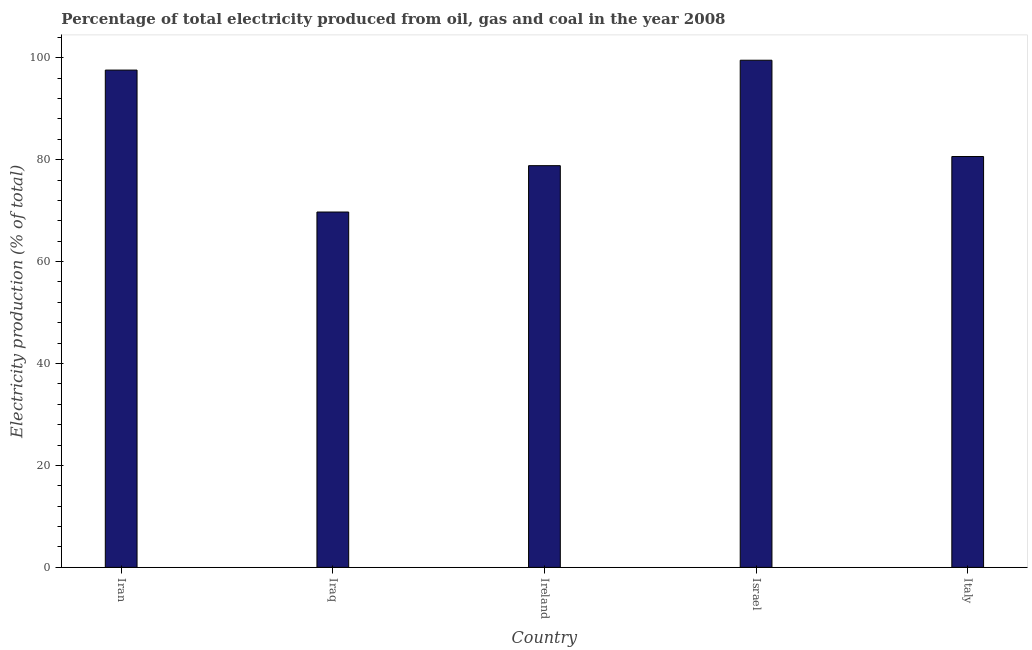Does the graph contain any zero values?
Offer a very short reply. No. What is the title of the graph?
Offer a very short reply. Percentage of total electricity produced from oil, gas and coal in the year 2008. What is the label or title of the Y-axis?
Offer a very short reply. Electricity production (% of total). What is the electricity production in Ireland?
Your answer should be compact. 78.82. Across all countries, what is the maximum electricity production?
Your answer should be compact. 99.51. Across all countries, what is the minimum electricity production?
Make the answer very short. 69.72. In which country was the electricity production maximum?
Keep it short and to the point. Israel. In which country was the electricity production minimum?
Your response must be concise. Iraq. What is the sum of the electricity production?
Offer a terse response. 426.25. What is the difference between the electricity production in Ireland and Israel?
Offer a very short reply. -20.69. What is the average electricity production per country?
Ensure brevity in your answer.  85.25. What is the median electricity production?
Ensure brevity in your answer.  80.61. What is the difference between the highest and the second highest electricity production?
Give a very brief answer. 1.93. What is the difference between the highest and the lowest electricity production?
Your answer should be very brief. 29.78. How many countries are there in the graph?
Your response must be concise. 5. What is the difference between two consecutive major ticks on the Y-axis?
Give a very brief answer. 20. Are the values on the major ticks of Y-axis written in scientific E-notation?
Offer a terse response. No. What is the Electricity production (% of total) of Iran?
Your answer should be compact. 97.58. What is the Electricity production (% of total) of Iraq?
Your answer should be very brief. 69.72. What is the Electricity production (% of total) of Ireland?
Keep it short and to the point. 78.82. What is the Electricity production (% of total) of Israel?
Provide a succinct answer. 99.51. What is the Electricity production (% of total) in Italy?
Your response must be concise. 80.61. What is the difference between the Electricity production (% of total) in Iran and Iraq?
Offer a terse response. 27.85. What is the difference between the Electricity production (% of total) in Iran and Ireland?
Provide a succinct answer. 18.75. What is the difference between the Electricity production (% of total) in Iran and Israel?
Make the answer very short. -1.93. What is the difference between the Electricity production (% of total) in Iran and Italy?
Your response must be concise. 16.96. What is the difference between the Electricity production (% of total) in Iraq and Ireland?
Give a very brief answer. -9.1. What is the difference between the Electricity production (% of total) in Iraq and Israel?
Your answer should be compact. -29.78. What is the difference between the Electricity production (% of total) in Iraq and Italy?
Provide a succinct answer. -10.89. What is the difference between the Electricity production (% of total) in Ireland and Israel?
Your answer should be very brief. -20.69. What is the difference between the Electricity production (% of total) in Ireland and Italy?
Keep it short and to the point. -1.79. What is the difference between the Electricity production (% of total) in Israel and Italy?
Give a very brief answer. 18.89. What is the ratio of the Electricity production (% of total) in Iran to that in Iraq?
Provide a short and direct response. 1.4. What is the ratio of the Electricity production (% of total) in Iran to that in Ireland?
Make the answer very short. 1.24. What is the ratio of the Electricity production (% of total) in Iran to that in Israel?
Your answer should be very brief. 0.98. What is the ratio of the Electricity production (% of total) in Iran to that in Italy?
Ensure brevity in your answer.  1.21. What is the ratio of the Electricity production (% of total) in Iraq to that in Ireland?
Your response must be concise. 0.89. What is the ratio of the Electricity production (% of total) in Iraq to that in Israel?
Give a very brief answer. 0.7. What is the ratio of the Electricity production (% of total) in Iraq to that in Italy?
Ensure brevity in your answer.  0.86. What is the ratio of the Electricity production (% of total) in Ireland to that in Israel?
Your answer should be compact. 0.79. What is the ratio of the Electricity production (% of total) in Israel to that in Italy?
Make the answer very short. 1.23. 